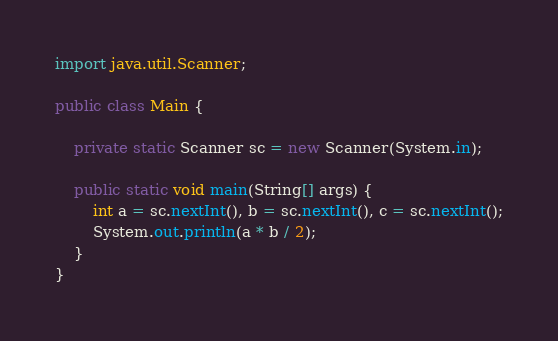<code> <loc_0><loc_0><loc_500><loc_500><_Java_>import java.util.Scanner;

public class Main {

    private static Scanner sc = new Scanner(System.in);

    public static void main(String[] args) {
        int a = sc.nextInt(), b = sc.nextInt(), c = sc.nextInt();
        System.out.println(a * b / 2);
    }
}</code> 